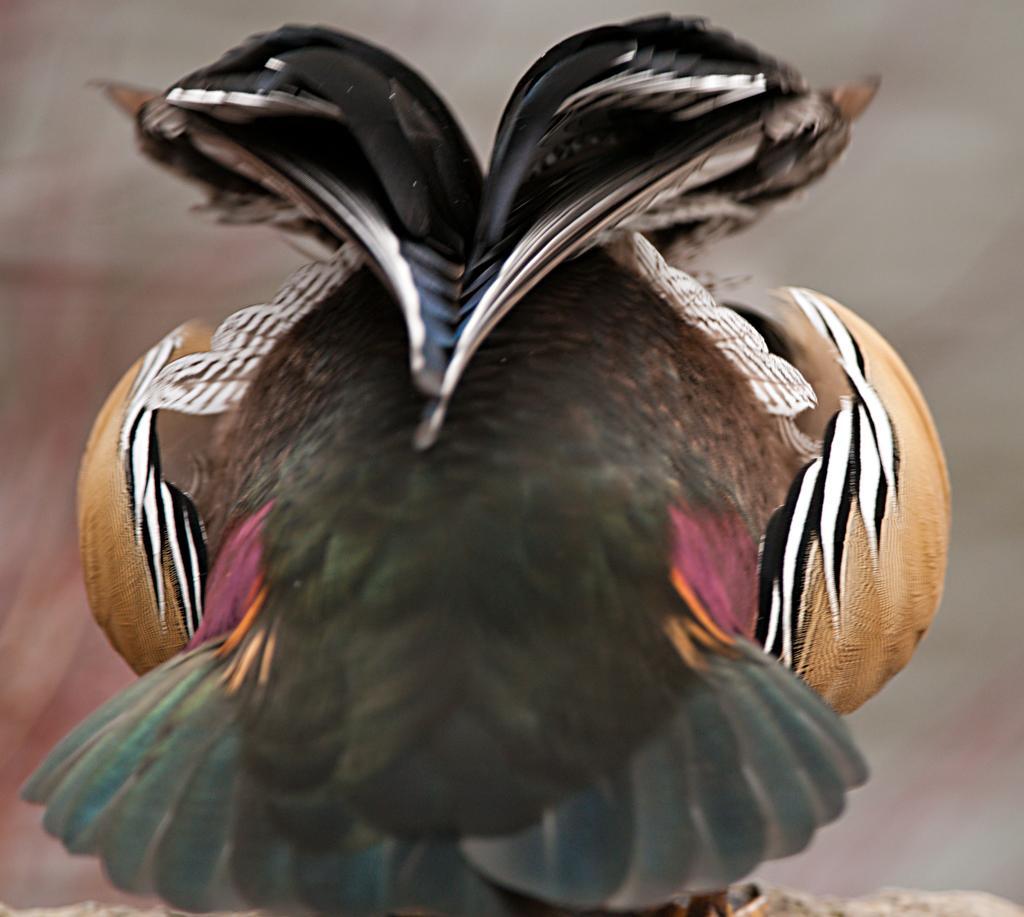Please provide a concise description of this image. In this image there is a bird on the rock. Background is blurry. 